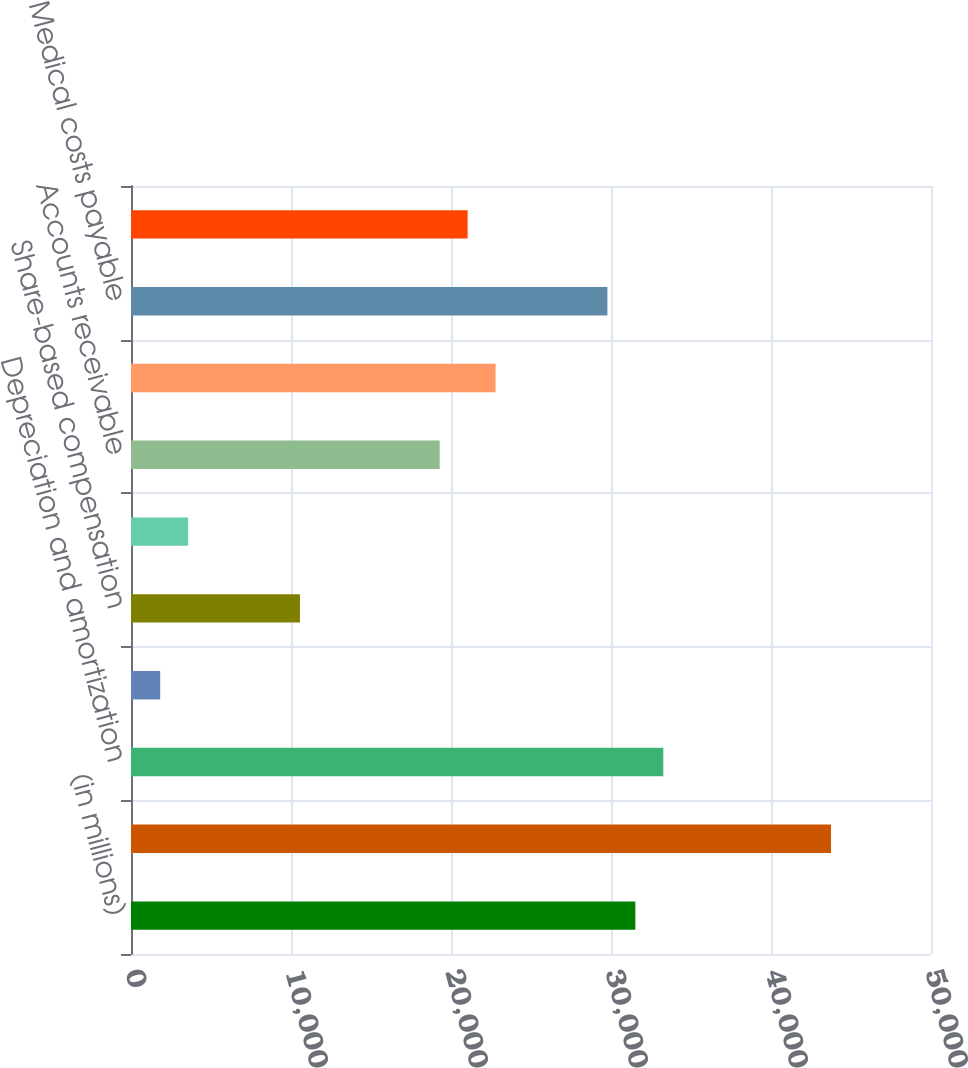Convert chart. <chart><loc_0><loc_0><loc_500><loc_500><bar_chart><fcel>(in millions)<fcel>Net earnings<fcel>Depreciation and amortization<fcel>Deferred income taxes<fcel>Share-based compensation<fcel>Other net<fcel>Accounts receivable<fcel>Other assets<fcel>Medical costs payable<fcel>Accounts payable and other<nl><fcel>31522.2<fcel>43750.5<fcel>33269.1<fcel>1824.9<fcel>10559.4<fcel>3571.8<fcel>19293.9<fcel>22787.7<fcel>29775.3<fcel>21040.8<nl></chart> 